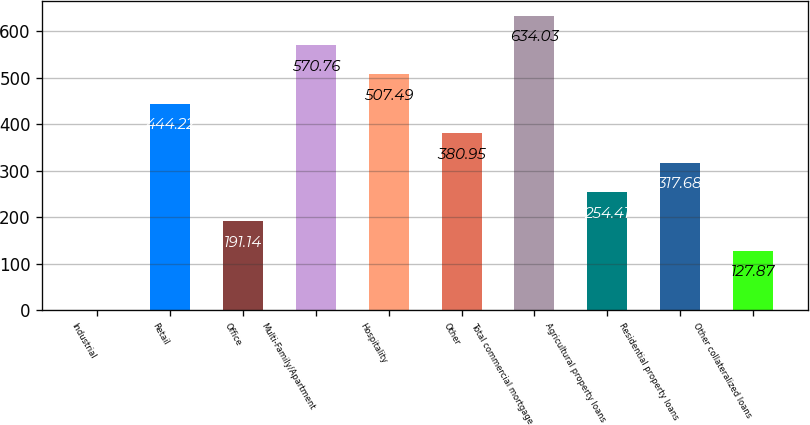<chart> <loc_0><loc_0><loc_500><loc_500><bar_chart><fcel>Industrial<fcel>Retail<fcel>Office<fcel>Multi-Family/Apartment<fcel>Hospitality<fcel>Other<fcel>Total commercial mortgage<fcel>Agricultural property loans<fcel>Residential property loans<fcel>Other collateralized loans<nl><fcel>1.33<fcel>444.22<fcel>191.14<fcel>570.76<fcel>507.49<fcel>380.95<fcel>634.03<fcel>254.41<fcel>317.68<fcel>127.87<nl></chart> 